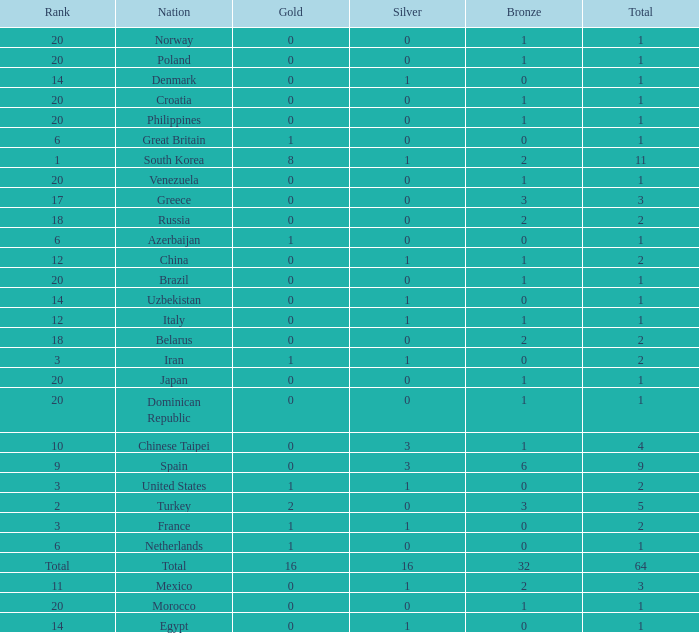How many total silvers does Russia have? 1.0. 